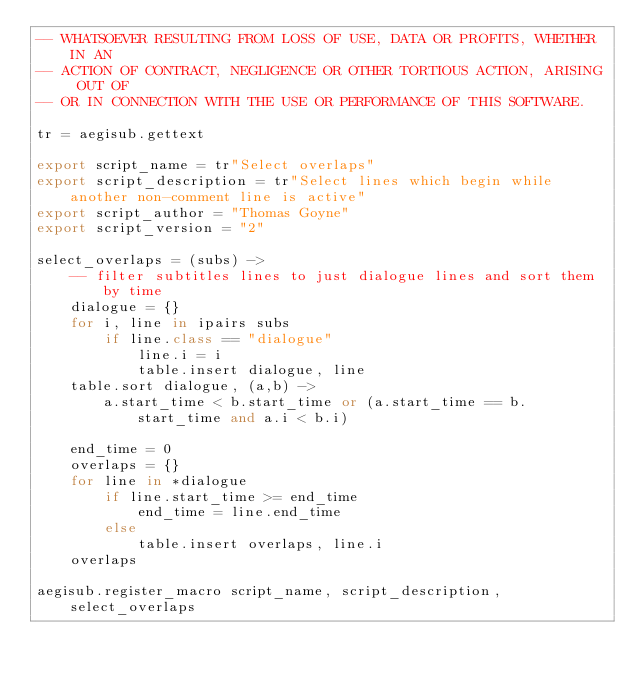<code> <loc_0><loc_0><loc_500><loc_500><_MoonScript_>-- WHATSOEVER RESULTING FROM LOSS OF USE, DATA OR PROFITS, WHETHER IN AN
-- ACTION OF CONTRACT, NEGLIGENCE OR OTHER TORTIOUS ACTION, ARISING OUT OF
-- OR IN CONNECTION WITH THE USE OR PERFORMANCE OF THIS SOFTWARE.

tr = aegisub.gettext

export script_name = tr"Select overlaps"
export script_description = tr"Select lines which begin while another non-comment line is active"
export script_author = "Thomas Goyne"
export script_version = "2"

select_overlaps = (subs) ->
    -- filter subtitles lines to just dialogue lines and sort them by time
    dialogue = {}
    for i, line in ipairs subs
        if line.class == "dialogue"
            line.i = i
            table.insert dialogue, line
    table.sort dialogue, (a,b) ->
        a.start_time < b.start_time or (a.start_time == b.start_time and a.i < b.i)

    end_time = 0
    overlaps = {}
    for line in *dialogue
        if line.start_time >= end_time
            end_time = line.end_time
        else
            table.insert overlaps, line.i
    overlaps

aegisub.register_macro script_name, script_description, select_overlaps
</code> 